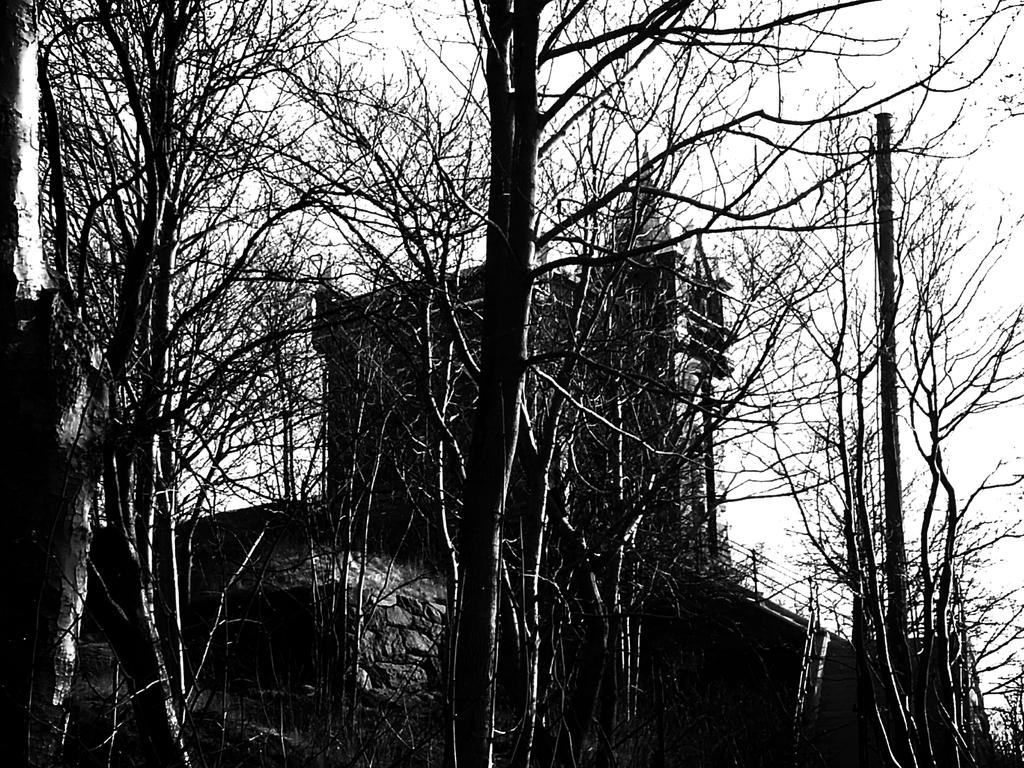What is the color scheme of the image? The image is black and white. What type of natural elements can be seen in the image? There are trees in the image. What architectural features are visible in the background? There is a wall, railing, and a building in the background of the image. What part of the natural environment is visible in the image? The sky is visible in the background of the image. What type of badge is being worn by the tree in the image? There are no badges present in the image, as it features trees, a wall, railing, a building, and the sky. What type of shock can be seen affecting the building in the image? There is no shock or any indication of damage to the building in the image. 